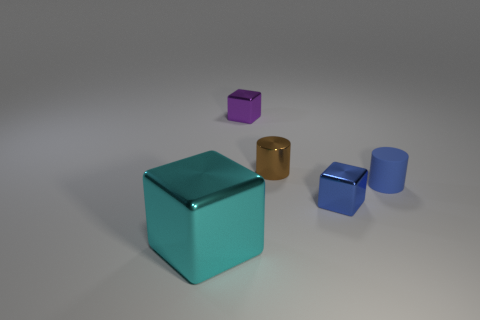Add 3 small blue cylinders. How many objects exist? 8 Subtract all cylinders. How many objects are left? 3 Subtract all big metallic cubes. Subtract all tiny things. How many objects are left? 0 Add 5 large metallic things. How many large metallic things are left? 6 Add 1 tiny purple metal cubes. How many tiny purple metal cubes exist? 2 Subtract 0 green spheres. How many objects are left? 5 